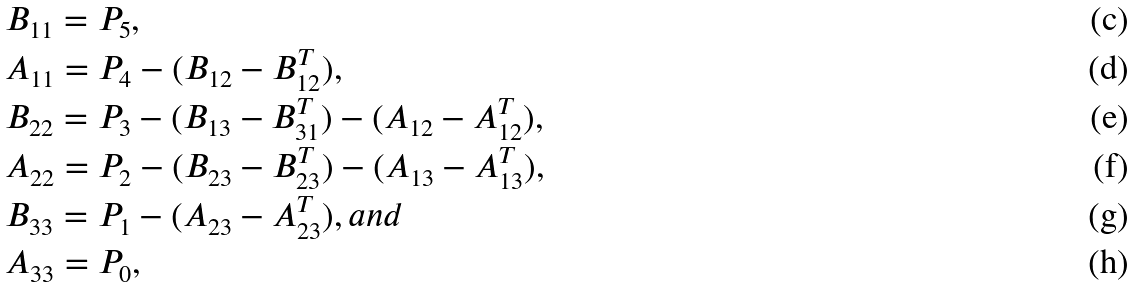Convert formula to latex. <formula><loc_0><loc_0><loc_500><loc_500>& B _ { 1 1 } = P _ { 5 } , \\ & A _ { 1 1 } = P _ { 4 } - ( B _ { 1 2 } - B _ { 1 2 } ^ { T } ) , \\ & B _ { 2 2 } = P _ { 3 } - ( B _ { 1 3 } - B _ { 3 1 } ^ { T } ) - ( A _ { 1 2 } - A _ { 1 2 } ^ { T } ) , \\ & A _ { 2 2 } = P _ { 2 } - ( B _ { 2 3 } - B _ { 2 3 } ^ { T } ) - ( A _ { 1 3 } - A _ { 1 3 } ^ { T } ) , \\ & B _ { 3 3 } = P _ { 1 } - ( A _ { 2 3 } - A _ { 2 3 } ^ { T } ) , a n d \\ & A _ { 3 3 } = P _ { 0 } ,</formula> 